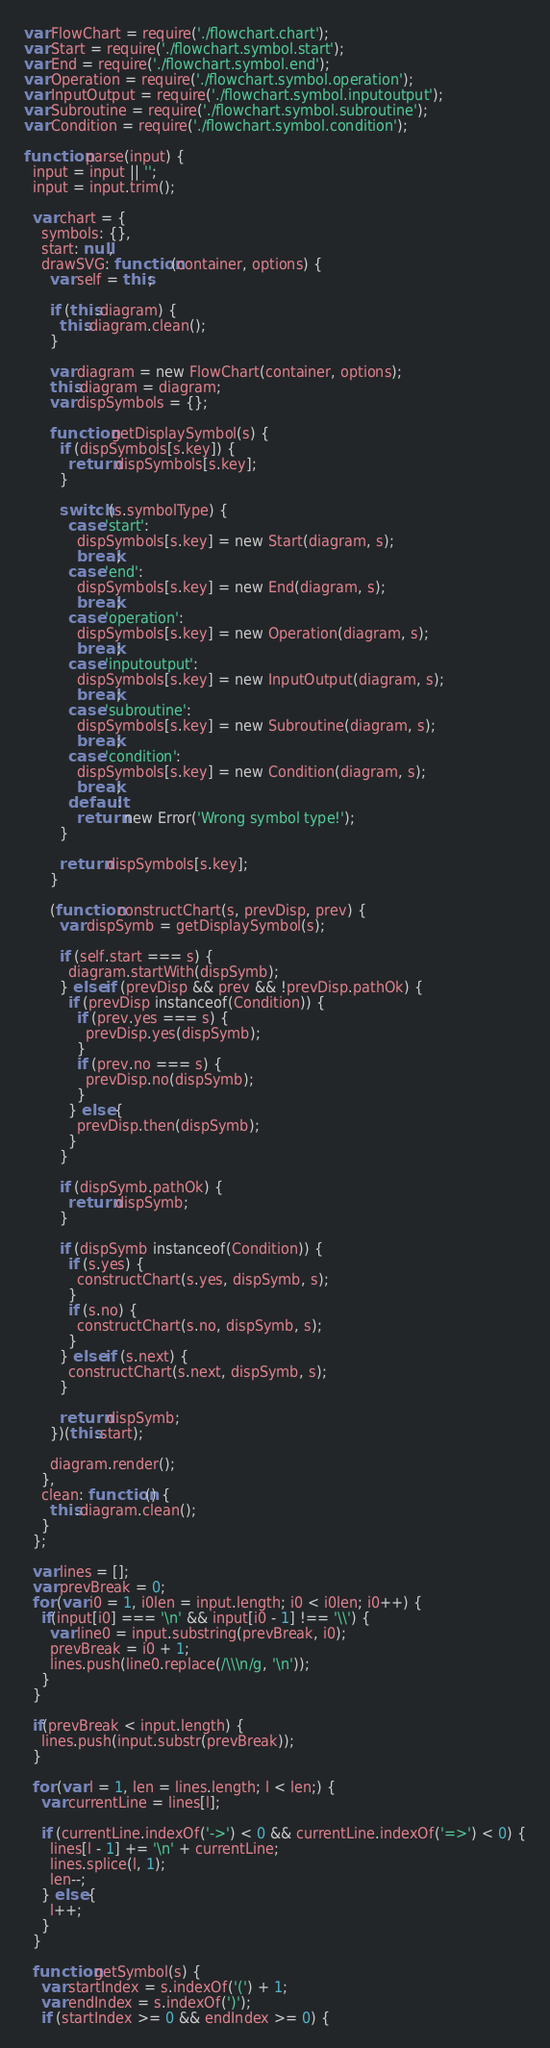<code> <loc_0><loc_0><loc_500><loc_500><_JavaScript_>var FlowChart = require('./flowchart.chart');
var Start = require('./flowchart.symbol.start');
var End = require('./flowchart.symbol.end');
var Operation = require('./flowchart.symbol.operation');
var InputOutput = require('./flowchart.symbol.inputoutput');
var Subroutine = require('./flowchart.symbol.subroutine');
var Condition = require('./flowchart.symbol.condition');

function parse(input) {
  input = input || '';
  input = input.trim();

  var chart = {
    symbols: {},
    start: null,
    drawSVG: function(container, options) {
      var self = this;

      if (this.diagram) {
        this.diagram.clean();
      }

      var diagram = new FlowChart(container, options);
      this.diagram = diagram;
      var dispSymbols = {};

      function getDisplaySymbol(s) {
        if (dispSymbols[s.key]) {
          return dispSymbols[s.key];
        }

        switch (s.symbolType) {
          case 'start':
            dispSymbols[s.key] = new Start(diagram, s);
            break;
          case 'end':
            dispSymbols[s.key] = new End(diagram, s);
            break;
          case 'operation':
            dispSymbols[s.key] = new Operation(diagram, s);
            break;
          case 'inputoutput':
            dispSymbols[s.key] = new InputOutput(diagram, s);
            break;
          case 'subroutine':
            dispSymbols[s.key] = new Subroutine(diagram, s);
            break;
          case 'condition':
            dispSymbols[s.key] = new Condition(diagram, s);
            break;
          default:
            return new Error('Wrong symbol type!');
        }

        return dispSymbols[s.key];
      }

      (function constructChart(s, prevDisp, prev) {
        var dispSymb = getDisplaySymbol(s);

        if (self.start === s) {
          diagram.startWith(dispSymb);
        } else if (prevDisp && prev && !prevDisp.pathOk) {
          if (prevDisp instanceof(Condition)) {
            if (prev.yes === s) {
              prevDisp.yes(dispSymb);
            }
            if (prev.no === s) {
              prevDisp.no(dispSymb);
            }
          } else {
            prevDisp.then(dispSymb);
          }
        }

        if (dispSymb.pathOk) {
          return dispSymb;
        }

        if (dispSymb instanceof(Condition)) {
          if (s.yes) {
            constructChart(s.yes, dispSymb, s);
          }
          if (s.no) {
            constructChart(s.no, dispSymb, s);
          }
        } else if (s.next) {
          constructChart(s.next, dispSymb, s);
        }

        return dispSymb;
      })(this.start);

      diagram.render();
    },
    clean: function() {
      this.diagram.clean();
    }
  };

  var lines = [];
  var prevBreak = 0;
  for (var i0 = 1, i0len = input.length; i0 < i0len; i0++) {
    if(input[i0] === '\n' && input[i0 - 1] !== '\\') {
      var line0 = input.substring(prevBreak, i0);
      prevBreak = i0 + 1;
      lines.push(line0.replace(/\\\n/g, '\n'));
    }
  }

  if(prevBreak < input.length) {
    lines.push(input.substr(prevBreak));
  }

  for (var l = 1, len = lines.length; l < len;) {
    var currentLine = lines[l];

    if (currentLine.indexOf('->') < 0 && currentLine.indexOf('=>') < 0) {
      lines[l - 1] += '\n' + currentLine;
      lines.splice(l, 1);
      len--;
    } else {
      l++;
    }
  }

  function getSymbol(s) {
    var startIndex = s.indexOf('(') + 1;
    var endIndex = s.indexOf(')');
    if (startIndex >= 0 && endIndex >= 0) {</code> 